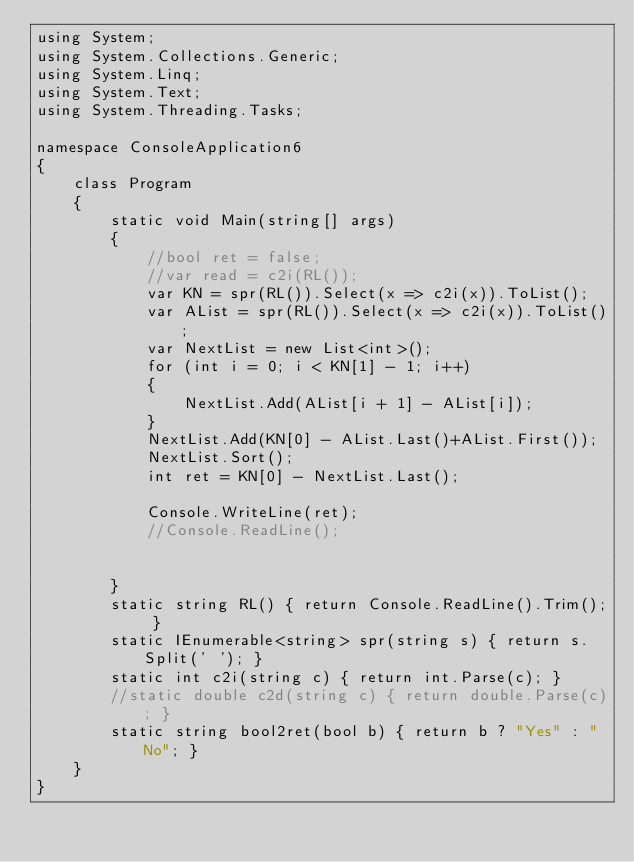Convert code to text. <code><loc_0><loc_0><loc_500><loc_500><_C#_>using System;
using System.Collections.Generic;
using System.Linq;
using System.Text;
using System.Threading.Tasks;

namespace ConsoleApplication6
{
    class Program
    {
        static void Main(string[] args)
        {
            //bool ret = false;
            //var read = c2i(RL());
            var KN = spr(RL()).Select(x => c2i(x)).ToList();
            var AList = spr(RL()).Select(x => c2i(x)).ToList();
            var NextList = new List<int>();
            for (int i = 0; i < KN[1] - 1; i++)
            {
                NextList.Add(AList[i + 1] - AList[i]);
            }
            NextList.Add(KN[0] - AList.Last()+AList.First());
            NextList.Sort();
            int ret = KN[0] - NextList.Last();

            Console.WriteLine(ret);
            //Console.ReadLine();


        }
        static string RL() { return Console.ReadLine().Trim(); }
        static IEnumerable<string> spr(string s) { return s.Split(' '); }
        static int c2i(string c) { return int.Parse(c); }
        //static double c2d(string c) { return double.Parse(c); }
        static string bool2ret(bool b) { return b ? "Yes" : "No"; }
    }
}
</code> 